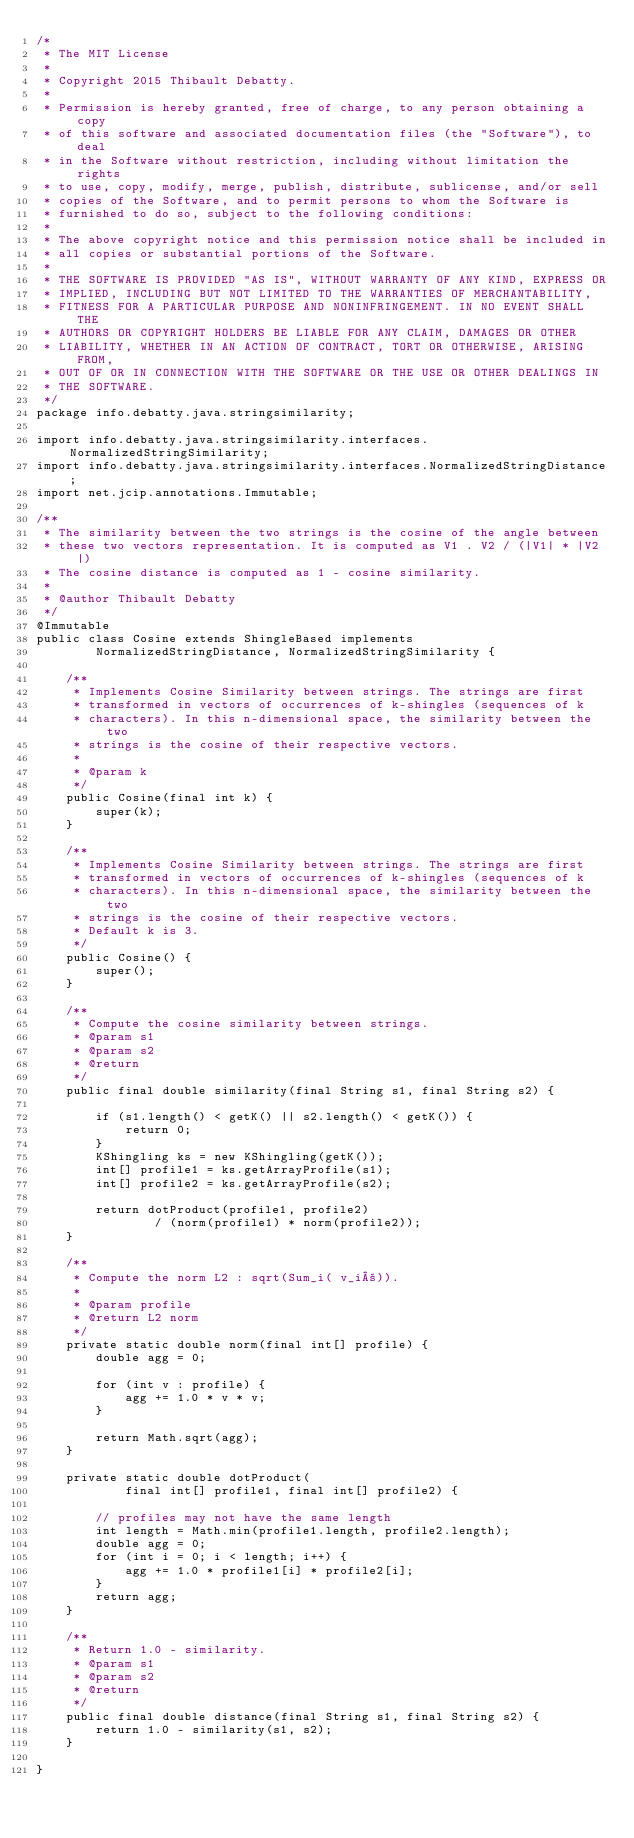Convert code to text. <code><loc_0><loc_0><loc_500><loc_500><_Java_>/*
 * The MIT License
 *
 * Copyright 2015 Thibault Debatty.
 *
 * Permission is hereby granted, free of charge, to any person obtaining a copy
 * of this software and associated documentation files (the "Software"), to deal
 * in the Software without restriction, including without limitation the rights
 * to use, copy, modify, merge, publish, distribute, sublicense, and/or sell
 * copies of the Software, and to permit persons to whom the Software is
 * furnished to do so, subject to the following conditions:
 *
 * The above copyright notice and this permission notice shall be included in
 * all copies or substantial portions of the Software.
 *
 * THE SOFTWARE IS PROVIDED "AS IS", WITHOUT WARRANTY OF ANY KIND, EXPRESS OR
 * IMPLIED, INCLUDING BUT NOT LIMITED TO THE WARRANTIES OF MERCHANTABILITY,
 * FITNESS FOR A PARTICULAR PURPOSE AND NONINFRINGEMENT. IN NO EVENT SHALL THE
 * AUTHORS OR COPYRIGHT HOLDERS BE LIABLE FOR ANY CLAIM, DAMAGES OR OTHER
 * LIABILITY, WHETHER IN AN ACTION OF CONTRACT, TORT OR OTHERWISE, ARISING FROM,
 * OUT OF OR IN CONNECTION WITH THE SOFTWARE OR THE USE OR OTHER DEALINGS IN
 * THE SOFTWARE.
 */
package info.debatty.java.stringsimilarity;

import info.debatty.java.stringsimilarity.interfaces.NormalizedStringSimilarity;
import info.debatty.java.stringsimilarity.interfaces.NormalizedStringDistance;
import net.jcip.annotations.Immutable;

/**
 * The similarity between the two strings is the cosine of the angle between
 * these two vectors representation. It is computed as V1 . V2 / (|V1| * |V2|)
 * The cosine distance is computed as 1 - cosine similarity.
 *
 * @author Thibault Debatty
 */
@Immutable
public class Cosine extends ShingleBased implements
        NormalizedStringDistance, NormalizedStringSimilarity {

    /**
     * Implements Cosine Similarity between strings. The strings are first
     * transformed in vectors of occurrences of k-shingles (sequences of k
     * characters). In this n-dimensional space, the similarity between the two
     * strings is the cosine of their respective vectors.
     *
     * @param k
     */
    public Cosine(final int k) {
        super(k);
    }

    /**
     * Implements Cosine Similarity between strings. The strings are first
     * transformed in vectors of occurrences of k-shingles (sequences of k
     * characters). In this n-dimensional space, the similarity between the two
     * strings is the cosine of their respective vectors.
     * Default k is 3.
     */
    public Cosine() {
        super();
    }

    /**
     * Compute the cosine similarity between strings.
     * @param s1
     * @param s2
     * @return
     */
    public final double similarity(final String s1, final String s2) {

        if (s1.length() < getK() || s2.length() < getK()) {
            return 0;
        }
        KShingling ks = new KShingling(getK());
        int[] profile1 = ks.getArrayProfile(s1);
        int[] profile2 = ks.getArrayProfile(s2);

        return dotProduct(profile1, profile2)
                / (norm(profile1) * norm(profile2));
    }

    /**
     * Compute the norm L2 : sqrt(Sum_i( v_i²)).
     *
     * @param profile
     * @return L2 norm
     */
    private static double norm(final int[] profile) {
        double agg = 0;

        for (int v : profile) {
            agg += 1.0 * v * v;
        }

        return Math.sqrt(agg);
    }

    private static double dotProduct(
            final int[] profile1, final int[] profile2) {

        // profiles may not have the same length
        int length = Math.min(profile1.length, profile2.length);
        double agg = 0;
        for (int i = 0; i < length; i++) {
            agg += 1.0 * profile1[i] * profile2[i];
        }
        return agg;
    }

    /**
     * Return 1.0 - similarity.
     * @param s1
     * @param s2
     * @return
     */
    public final double distance(final String s1, final String s2) {
        return 1.0 - similarity(s1, s2);
    }

}
</code> 